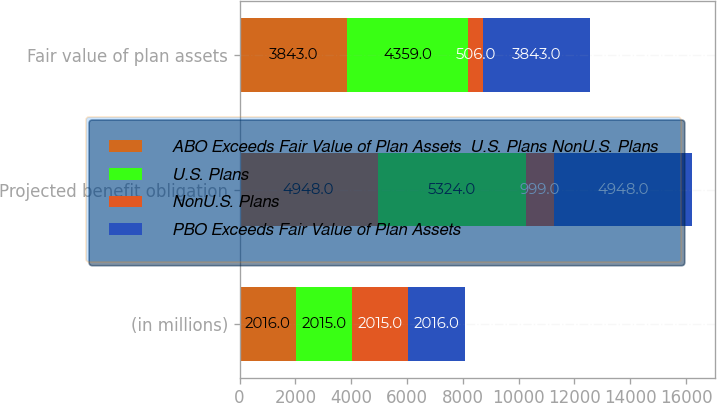Convert chart to OTSL. <chart><loc_0><loc_0><loc_500><loc_500><stacked_bar_chart><ecel><fcel>(in millions)<fcel>Projected benefit obligation<fcel>Fair value of plan assets<nl><fcel>ABO Exceeds Fair Value of Plan Assets  U.S. Plans NonU.S. Plans<fcel>2016<fcel>4948<fcel>3843<nl><fcel>U.S. Plans<fcel>2015<fcel>5324<fcel>4359<nl><fcel>NonU.S. Plans<fcel>2015<fcel>999<fcel>506<nl><fcel>PBO Exceeds Fair Value of Plan Assets<fcel>2016<fcel>4948<fcel>3843<nl></chart> 